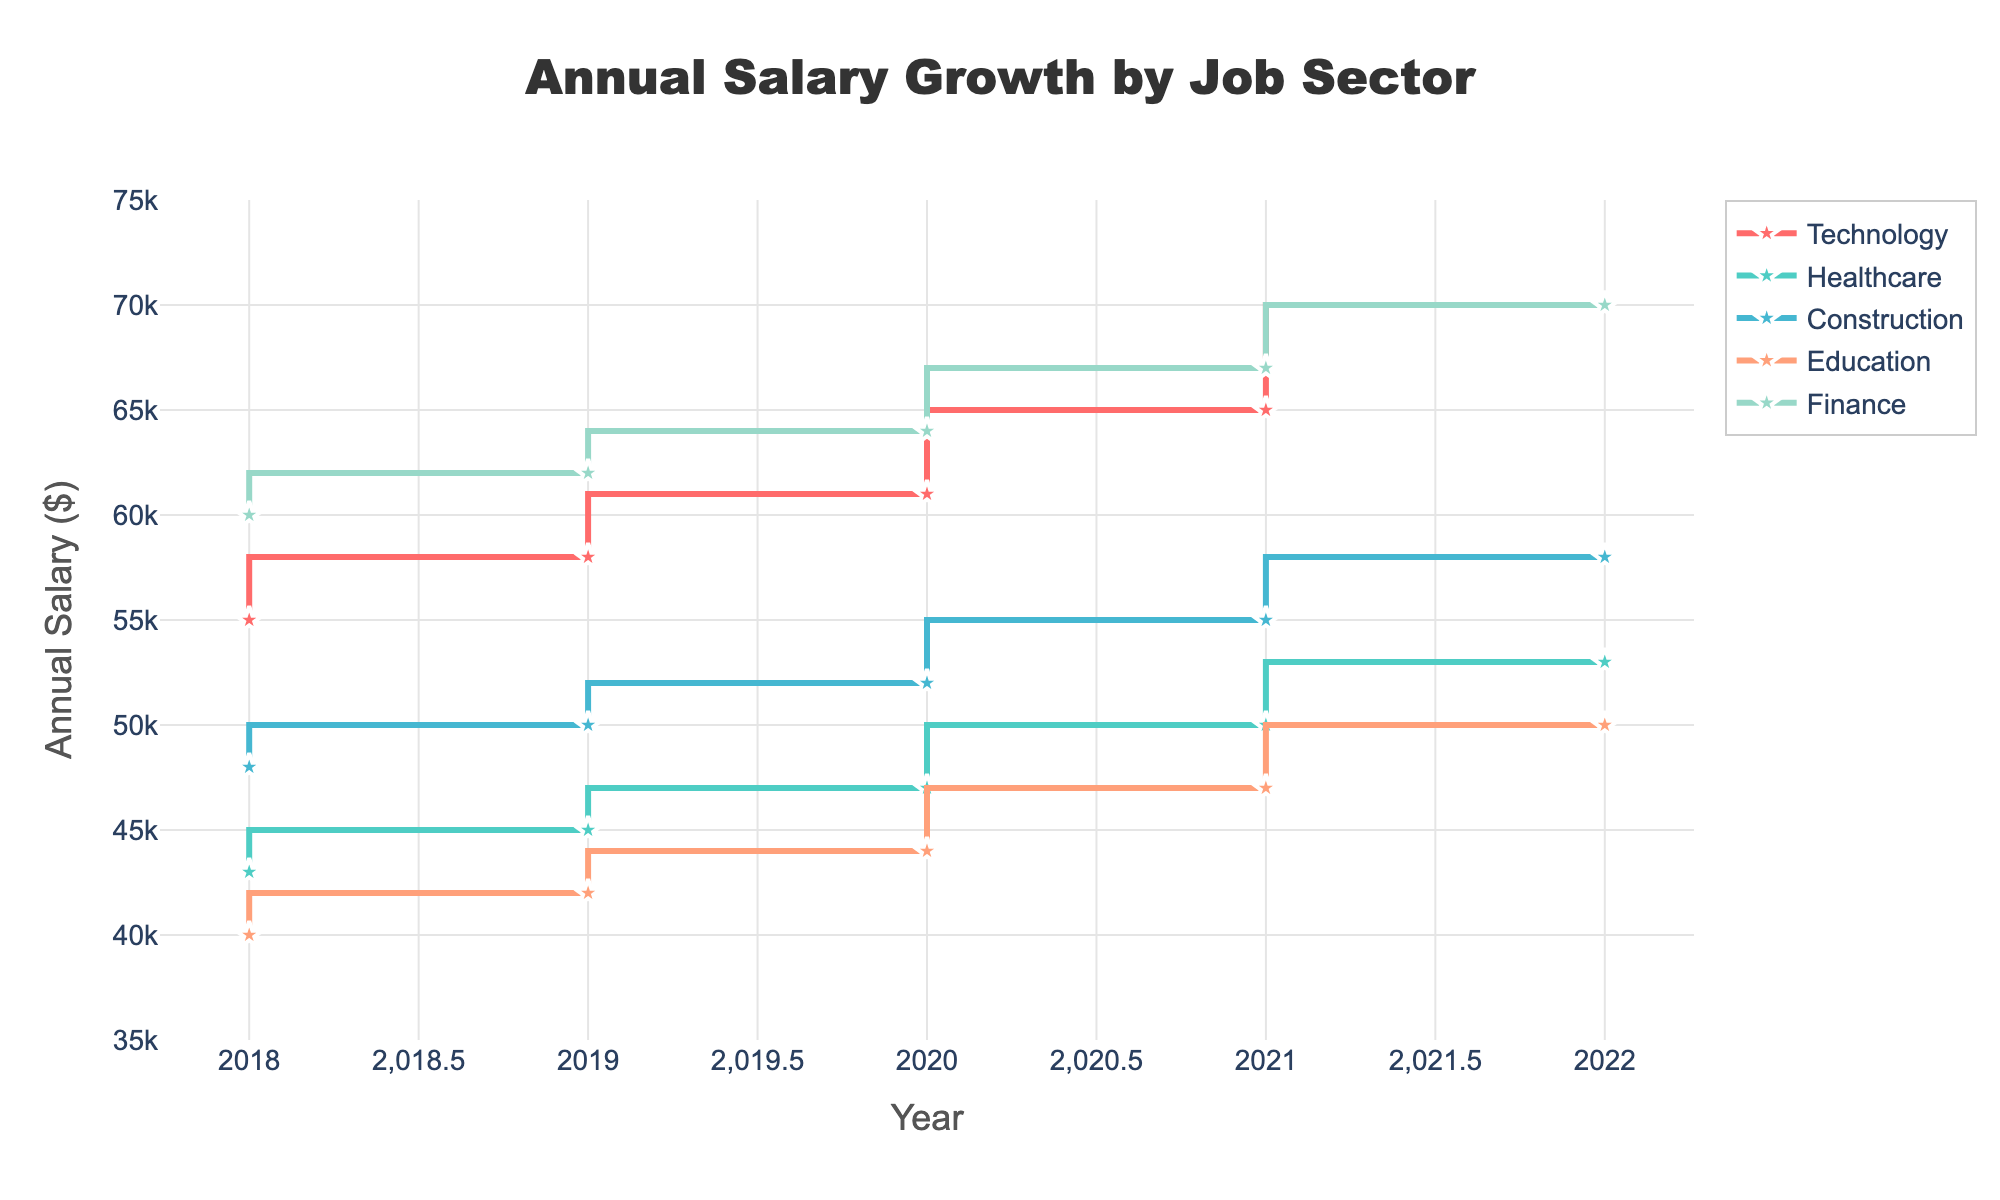What is the title of the plot? The title of the plot is written at the top, centrally aligned. It reads "Annual Salary Growth by Job Sector".
Answer: Annual Salary Growth by Job Sector Which job sector had the highest annual salary in 2018? By looking at the starting points of the lines representing each job sector on the left side of the plot, Technology has the highest annual salary of 55,000 in 2018.
Answer: Technology What was the annual salary for the Healthcare sector in 2019? Trace the line corresponding to Healthcare and look for the marker above the year 2019. It shows 45,000.
Answer: 45,000 How many years are represented in the plot? The x-axis labels indicate years from 2018 to 2022. That's a span of 5 years.
Answer: 5 Which job sector saw the largest overall increase in annual salary over the years? Compare the starting (2018) and ending (2022) points for each line. Technology increased from 55,000 to 70,000, which is the largest increase of 15,000.
Answer: Technology What is the average annual salary for the Construction sector across all years? Sum up the annual salaries for Construction from 2018 to 2022 and divide by the number of years (48,000 + 50,000 + 52,000 + 55,000 + 58,000) / 5 = 52,600.
Answer: 52,600 Which two sectors had the closest annual salaries in 2022? Look at the end points for 2022 and compare their values. Construction (58,000) and Healthcare (53,000) have the closest salaries with a difference of 5,000.
Answer: Construction and Healthcare By how much did the annual salary for the Education sector increase from 2018 to 2022? Look at the line representing Education. In 2018, the salary was 40,000, and in 2022, it reached 50,000. The increase is 50,000 - 40,000 = 10,000.
Answer: 10,000 Which sector shows a steady increase without any fluctuation over the years? Scan each line to observe their trends. All lines show a steady upward movement without any drops, so no sector shows fluctuation.
Answer: All sectors (Technology, Healthcare, Construction, Education, Finance) What was the salary growth for Finance from 2020 to 2021? Find the vertical difference in the Finance line between 2020 and 2021, moving from 64,000 to 67,000. The growth is 67,000 - 64,000 = 3,000.
Answer: 3,000 